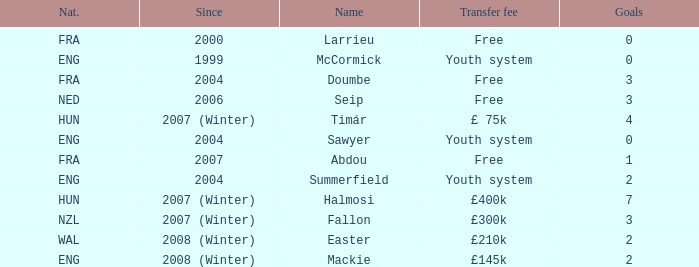In which year did the player with a £75k transfer fee begin their career? 2007 (Winter). 